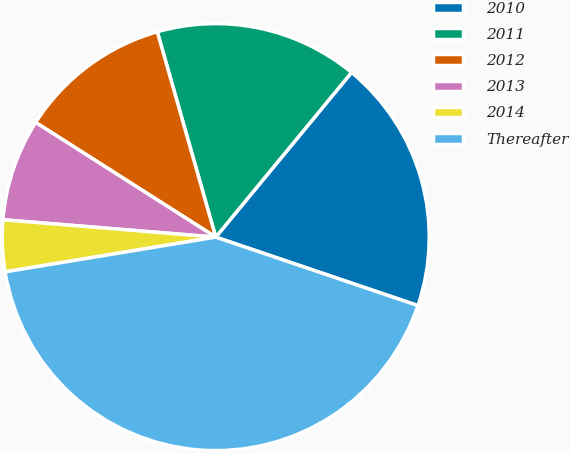Convert chart. <chart><loc_0><loc_0><loc_500><loc_500><pie_chart><fcel>2010<fcel>2011<fcel>2012<fcel>2013<fcel>2014<fcel>Thereafter<nl><fcel>19.22%<fcel>15.39%<fcel>11.56%<fcel>7.73%<fcel>3.9%<fcel>42.2%<nl></chart> 